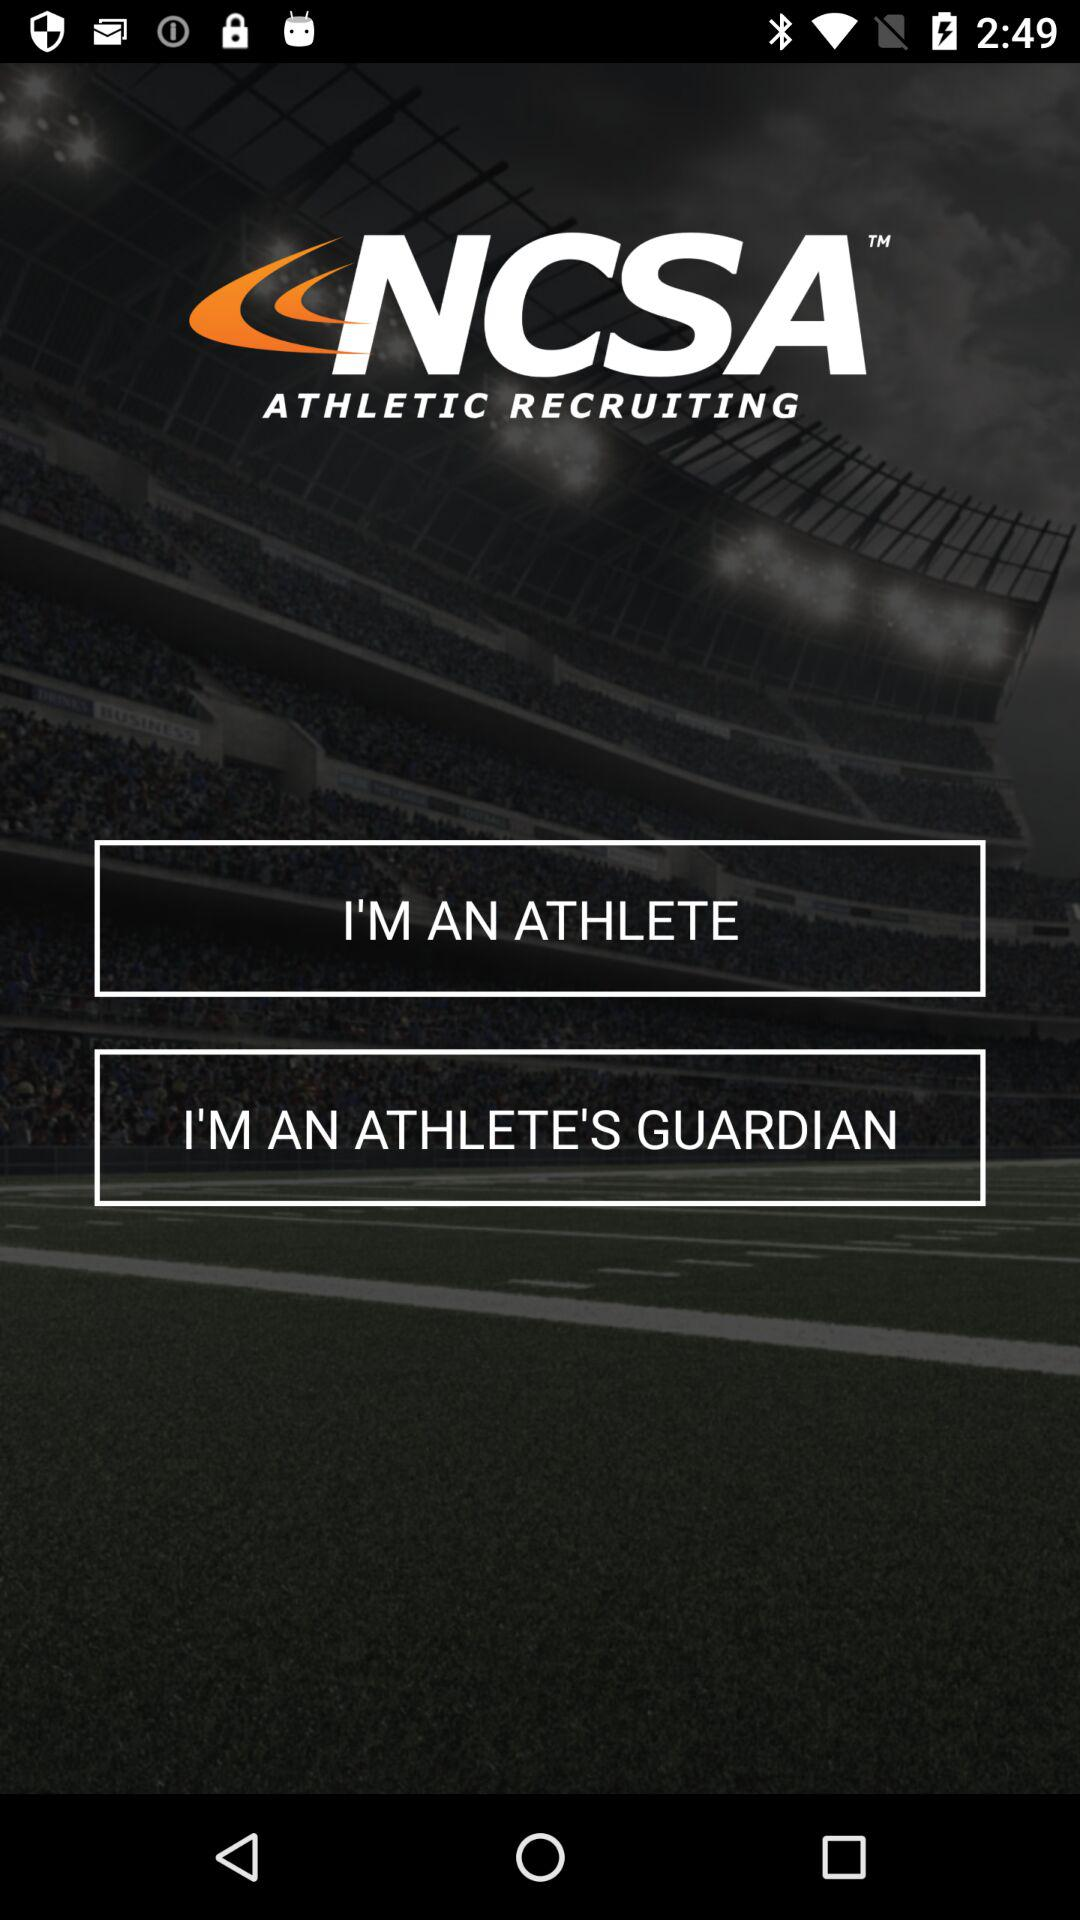What is the app name? The app name is "NCSA ATHLETIC RECRUITING". 